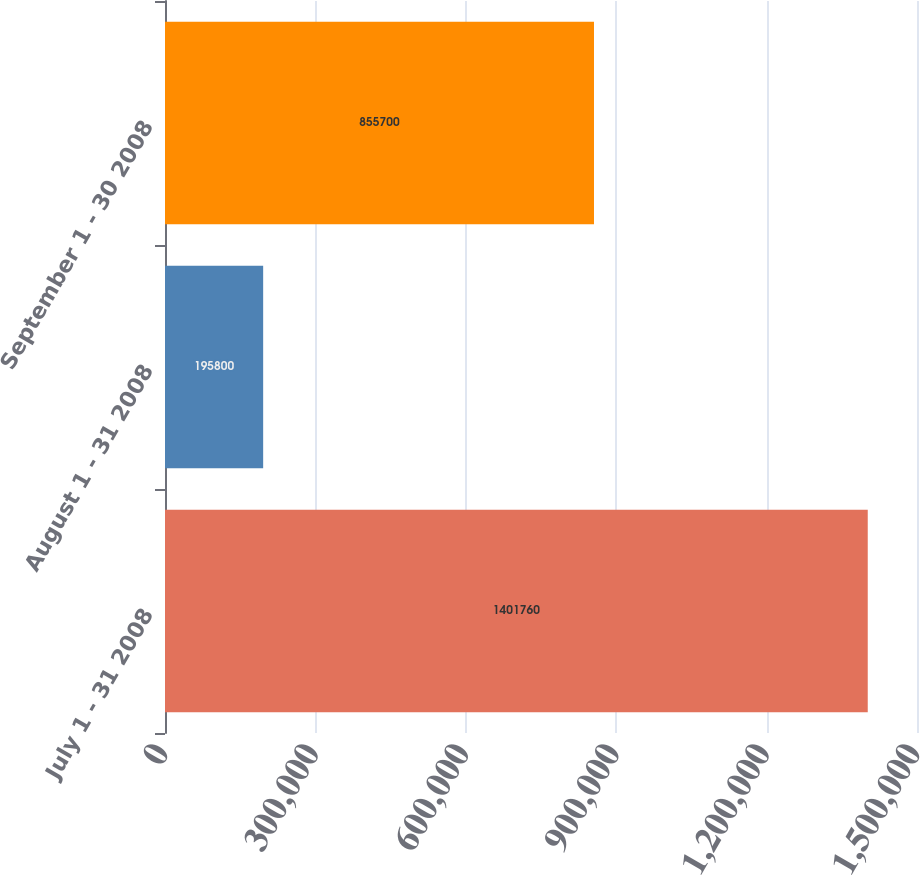Convert chart. <chart><loc_0><loc_0><loc_500><loc_500><bar_chart><fcel>July 1 - 31 2008<fcel>August 1 - 31 2008<fcel>September 1 - 30 2008<nl><fcel>1.40176e+06<fcel>195800<fcel>855700<nl></chart> 